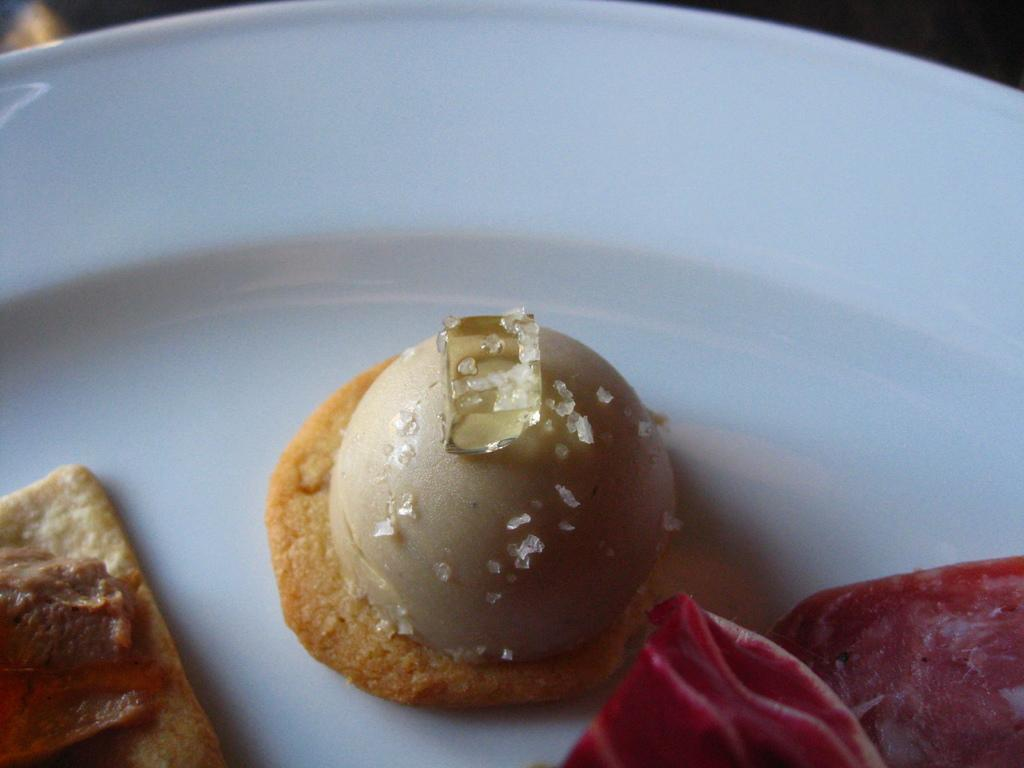What is the main object in the image? There is a table in the image. What is on the table? There are food items on the table. What can be seen in the background of the image? The background of the image appears to be black. Is there a hook hanging from the ceiling in the image? There is no hook hanging from the ceiling in the image. What type of crime is being committed in the image? There is no crime being committed in the image; it features a table with food items and a black background. 